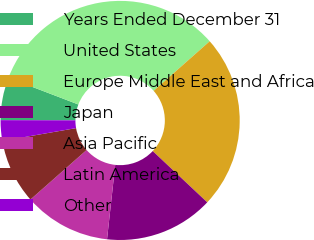Convert chart. <chart><loc_0><loc_0><loc_500><loc_500><pie_chart><fcel>Years Ended December 31<fcel>United States<fcel>Europe Middle East and Africa<fcel>Japan<fcel>Asia Pacific<fcel>Latin America<fcel>Other<nl><fcel>5.77%<fcel>32.67%<fcel>23.53%<fcel>14.74%<fcel>11.75%<fcel>8.76%<fcel>2.78%<nl></chart> 